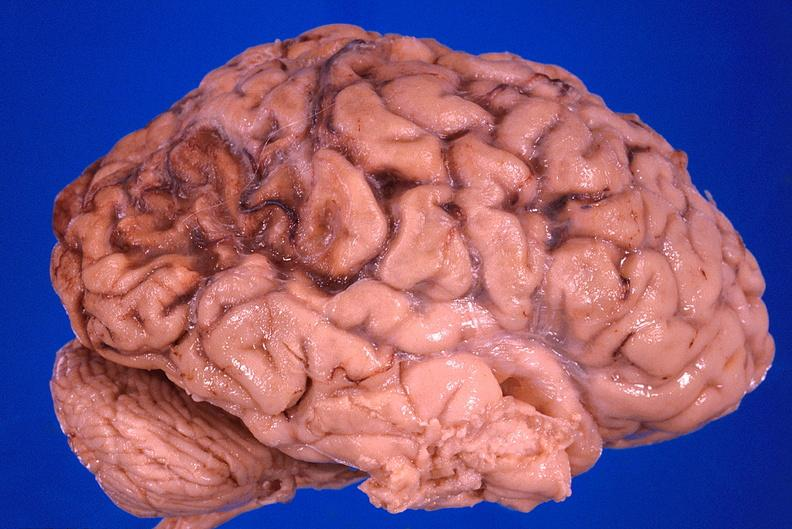does this image show brain, old infarcts, embolic?
Answer the question using a single word or phrase. Yes 